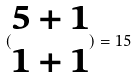Convert formula to latex. <formula><loc_0><loc_0><loc_500><loc_500>( \begin{matrix} 5 + 1 \\ 1 + 1 \end{matrix} ) = 1 5</formula> 